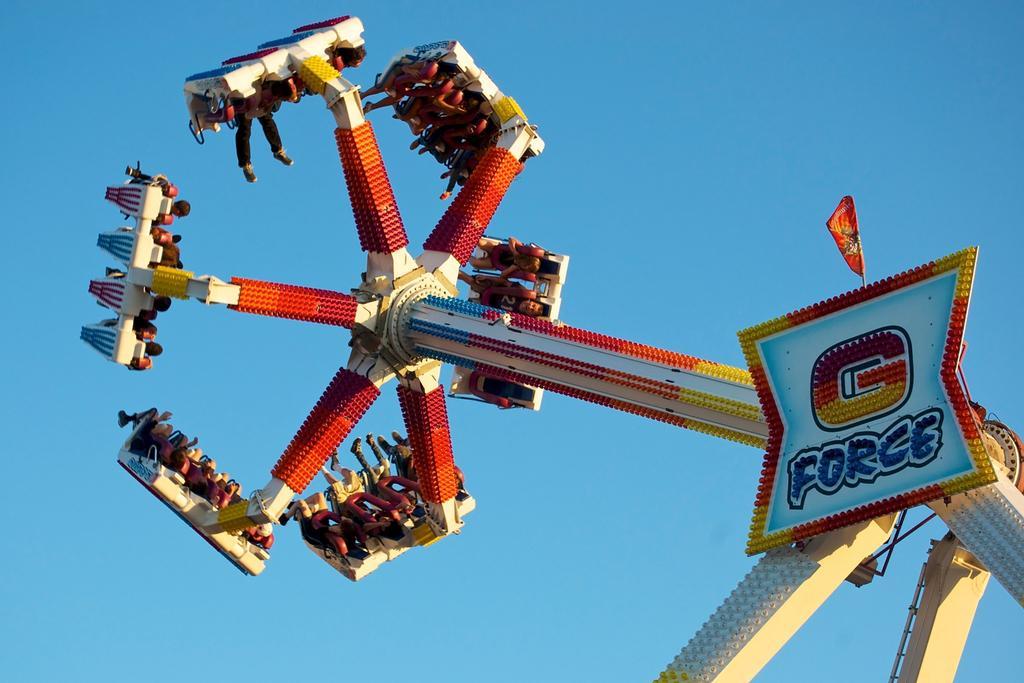Can you describe this image briefly? In the image in the center we can see one amusement ride,banner,flag and few people were sitting on it. In the background we can see sky. 